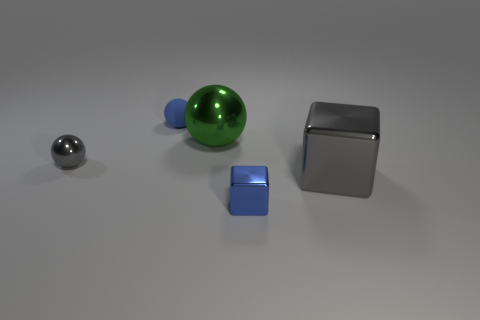What number of brown shiny objects have the same size as the green metal ball?
Make the answer very short. 0. The thing that is the same color as the small rubber ball is what shape?
Offer a terse response. Cube. Are the sphere left of the blue sphere and the blue thing to the left of the small blue metal cube made of the same material?
Provide a succinct answer. No. Are there any other things that have the same shape as the big green metallic thing?
Your answer should be compact. Yes. What is the color of the small matte thing?
Provide a short and direct response. Blue. What number of other objects have the same shape as the large gray thing?
Your response must be concise. 1. The cube that is the same size as the green thing is what color?
Ensure brevity in your answer.  Gray. Are there any red cylinders?
Offer a terse response. No. There is a tiny thing that is on the right side of the tiny blue matte sphere; what is its shape?
Keep it short and to the point. Cube. What number of things are on the right side of the green metallic sphere and on the left side of the green sphere?
Provide a short and direct response. 0. 